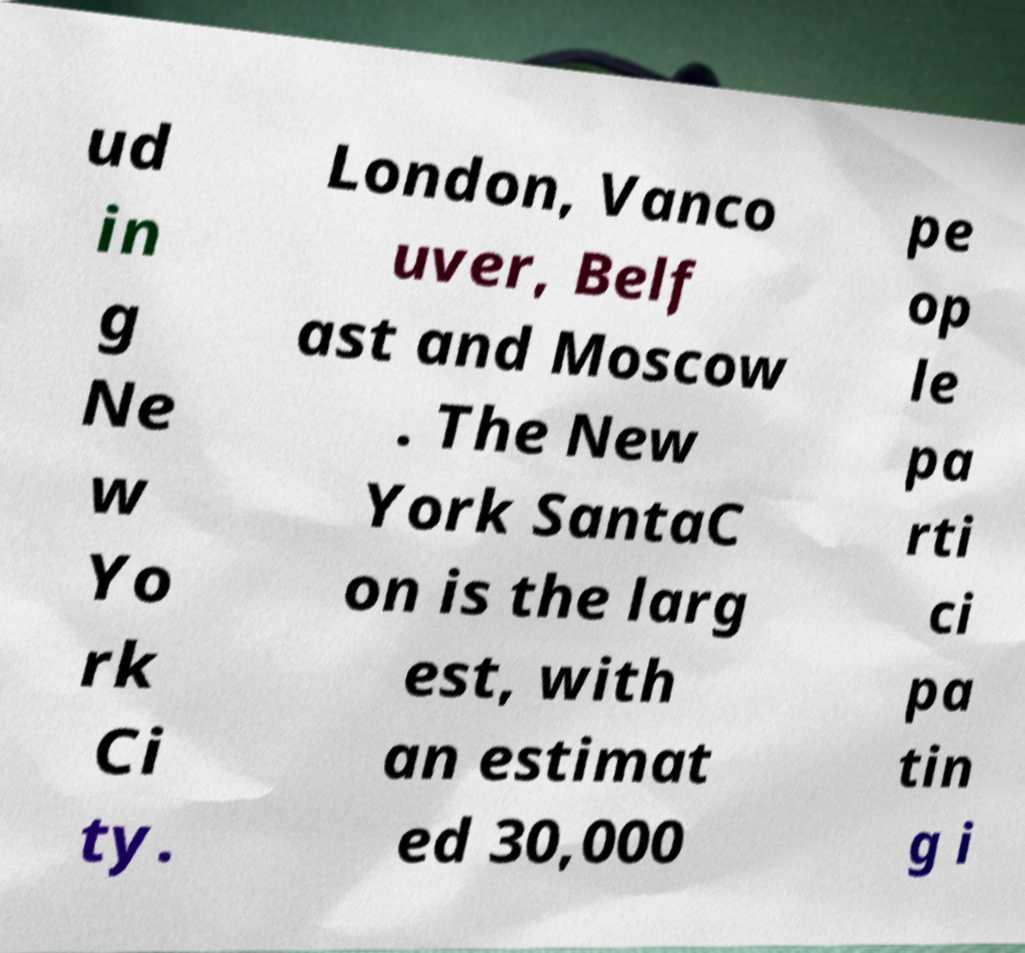Could you assist in decoding the text presented in this image and type it out clearly? ud in g Ne w Yo rk Ci ty. London, Vanco uver, Belf ast and Moscow . The New York SantaC on is the larg est, with an estimat ed 30,000 pe op le pa rti ci pa tin g i 